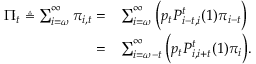Convert formula to latex. <formula><loc_0><loc_0><loc_500><loc_500>\begin{array} { r l } { \Pi _ { t } \triangle q \sum _ { i = \omega } ^ { \infty } \pi _ { i , t } = } & { \sum _ { i = \omega } ^ { \infty } \left ( p _ { t } P _ { i - t , i } ^ { t } ( 1 ) \pi _ { i - t } \right ) } \\ { = } & { \sum _ { i = \omega - t } ^ { \infty } \left ( p _ { t } P _ { i , i + t } ^ { t } ( 1 ) \pi _ { i } \right ) . } \end{array}</formula> 